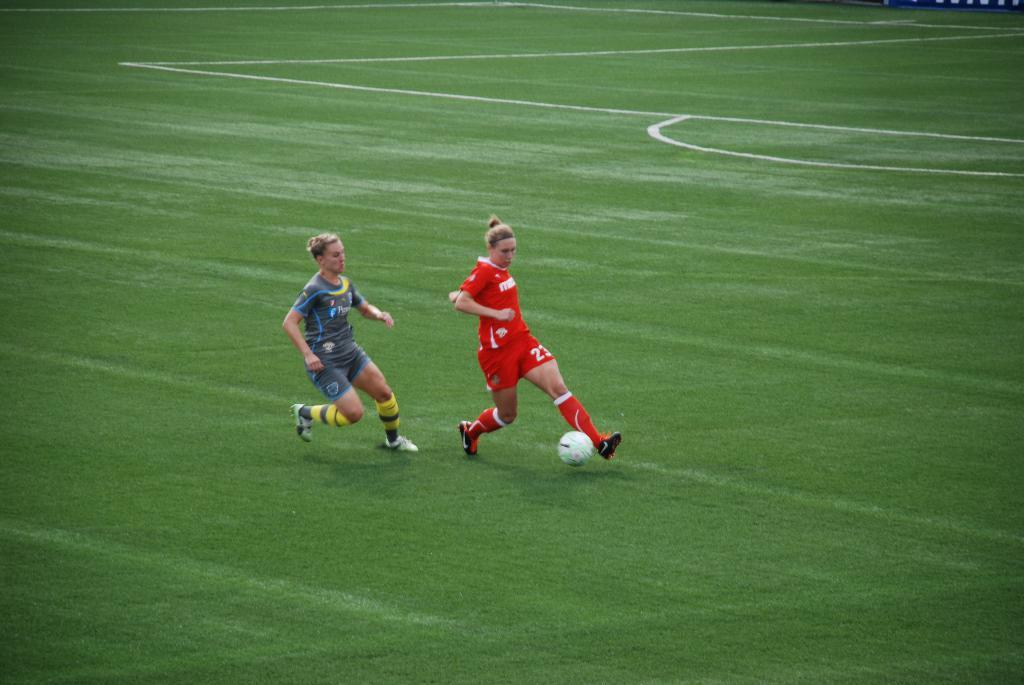<image>
Summarize the visual content of the image. Number 23 on the red team has the ball is making her way to the goal. 